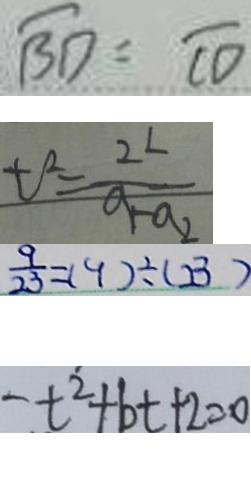<formula> <loc_0><loc_0><loc_500><loc_500>\widehat { B D } = \widehat { C D } 
 t ^ { 2 } = \frac { 2 L } { a _ { 1 } - a _ { 2 } } 
 \frac { 9 } { 2 3 } = ( 9 ) \div ( 2 3 ) 
 t ^ { 2 } + b t + 2 = 0</formula> 